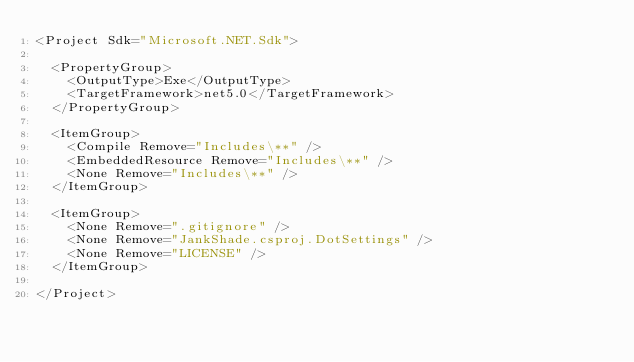Convert code to text. <code><loc_0><loc_0><loc_500><loc_500><_XML_><Project Sdk="Microsoft.NET.Sdk">

  <PropertyGroup>
    <OutputType>Exe</OutputType>
    <TargetFramework>net5.0</TargetFramework>
  </PropertyGroup>

  <ItemGroup>
    <Compile Remove="Includes\**" />
    <EmbeddedResource Remove="Includes\**" />
    <None Remove="Includes\**" />
  </ItemGroup>

  <ItemGroup>
    <None Remove=".gitignore" />
    <None Remove="JankShade.csproj.DotSettings" />
    <None Remove="LICENSE" />
  </ItemGroup>

</Project>
</code> 